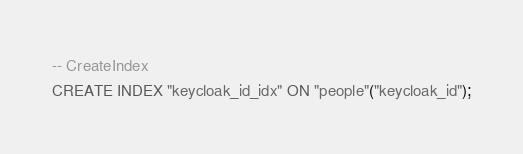<code> <loc_0><loc_0><loc_500><loc_500><_SQL_>-- CreateIndex
CREATE INDEX "keycloak_id_idx" ON "people"("keycloak_id");
</code> 